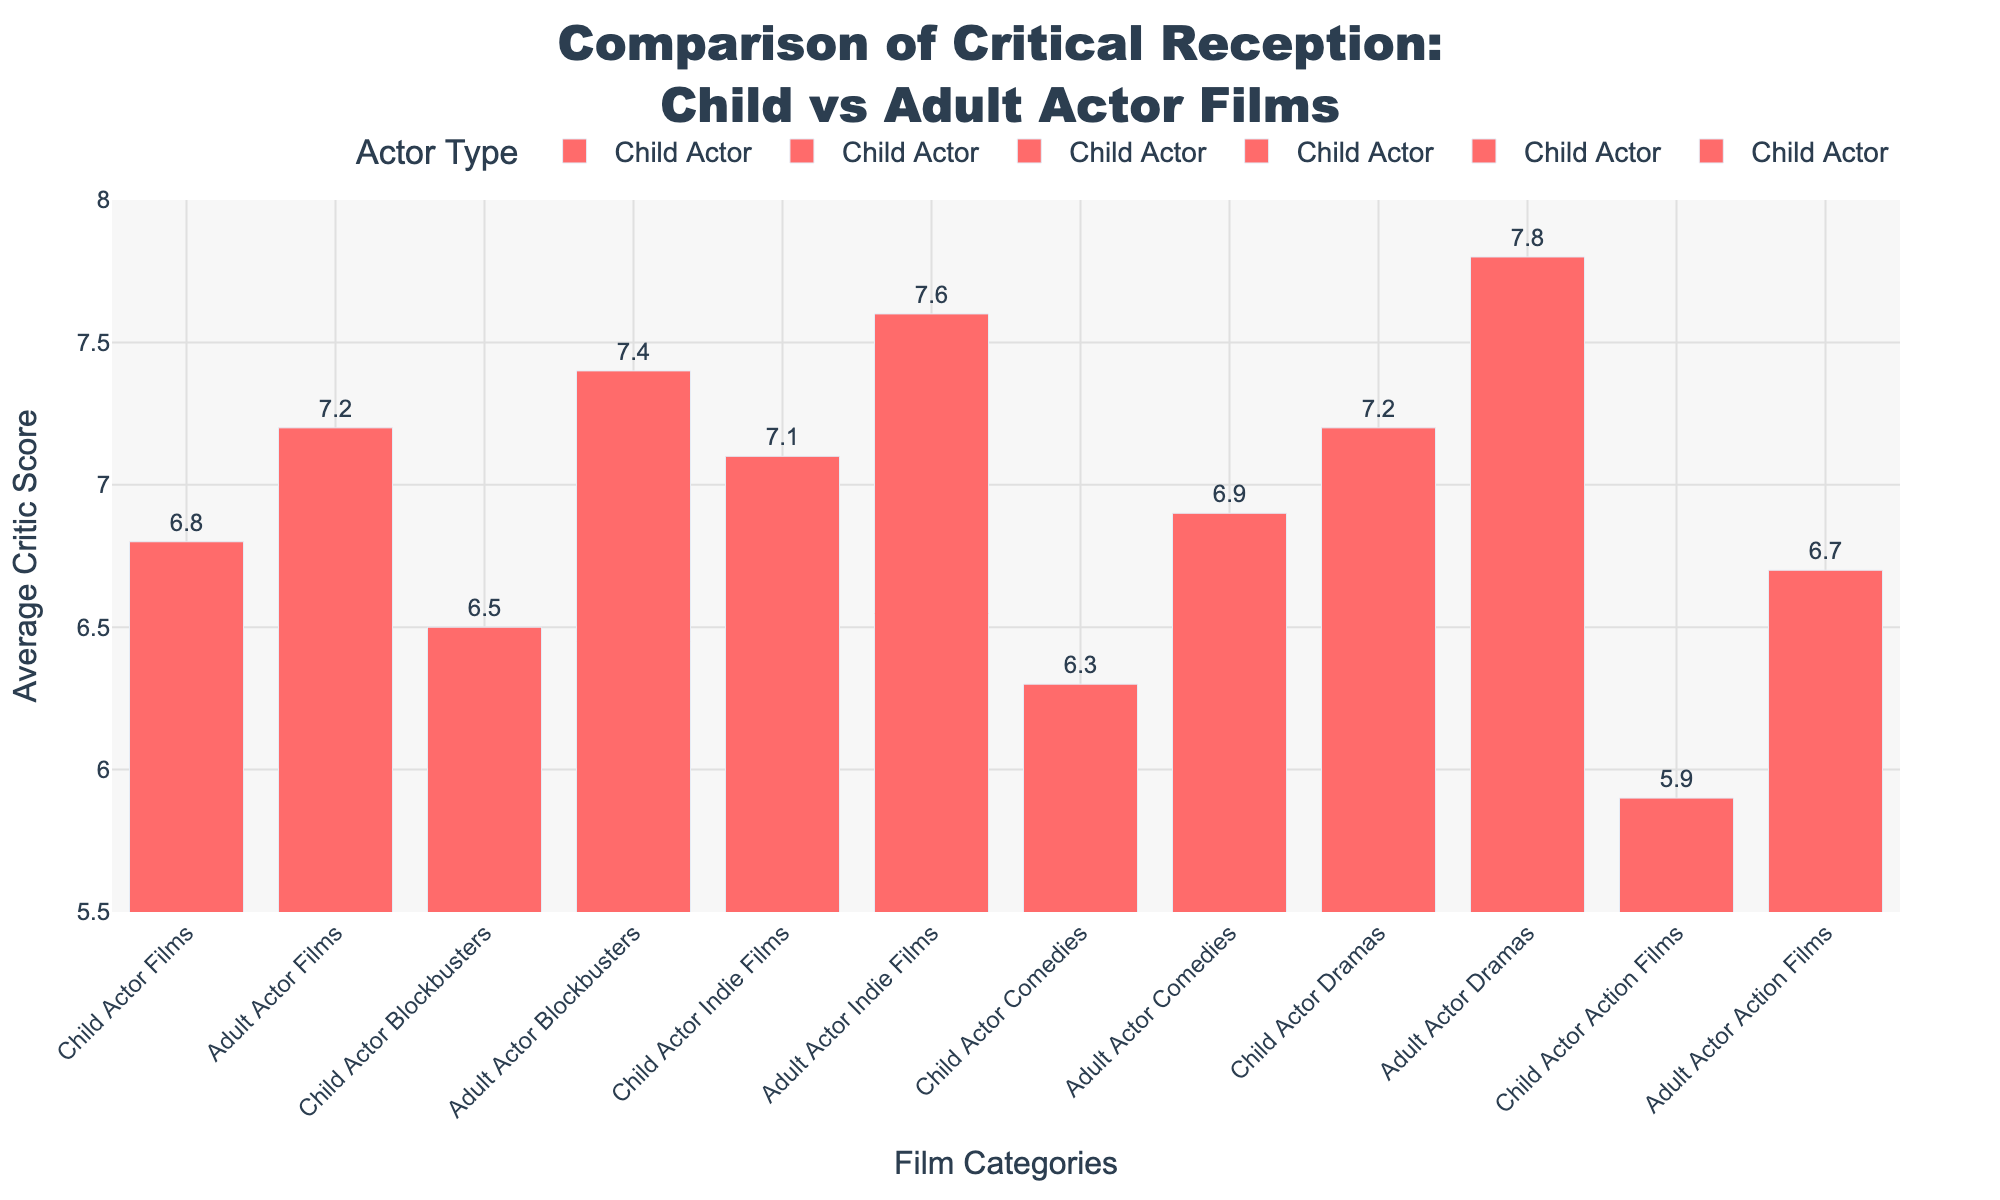What category of films has the highest average critic score for child actor films? Look for the category with the highest value in the child actor series. "Child Actor Dramas" has the highest score of 7.2.
Answer: Child Actor Dramas Which category of films shows the biggest difference in average critic scores between child actors and adult actors? Calculate the differences for each category:  
- Child Actor Films vs Adult Actor Films: 7.2 - 6.8 = 0.4  
- Child Actor Blockbusters vs Adult Actor Blockbusters: 7.4 - 6.5 = 0.9  
- Child Actor Indie Films vs Adult Actor Indie Films: 7.6 - 7.1 = 0.5  
- Child Actor Comedies vs Adult Actor Comedies: 6.9 - 6.3 = 0.6  
- Child Actor Dramas vs Adult Actor Dramas: 7.8 - 7.2 = 0.6  
- Child Actor Action Films vs Adult Actor Action Films: 6.7 - 5.9 = 0.8  
The biggest difference is 0.9 for blockbusters.
Answer: Blockbusters Among comedies, which actor type has a higher average critic score? Compare the average critic scores for comedies: "Child Actor Comedies" has 6.3 and "Adult Actor Comedies" has 6.9.
Answer: Adult Actor Which film category has the lowest average critic score amongst child actor films? Look for the category with the lowest bar in the child actor series, which is "Child Actor Action Films" with a score of 5.9.
Answer: Child Actor Action Films 